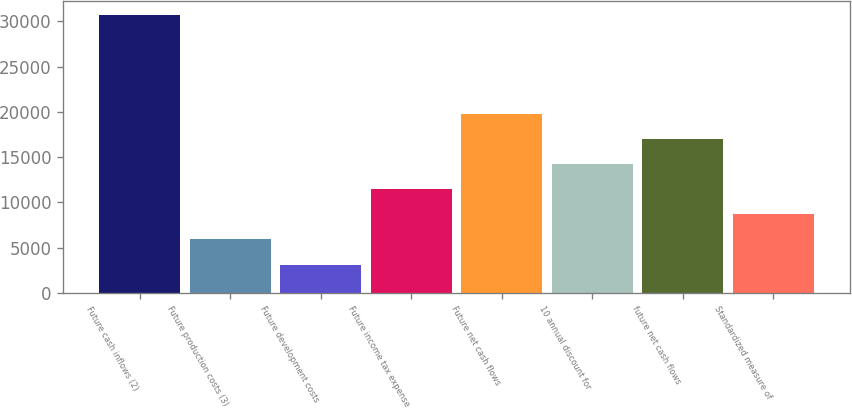Convert chart to OTSL. <chart><loc_0><loc_0><loc_500><loc_500><bar_chart><fcel>Future cash inflows (2)<fcel>Future production costs (3)<fcel>Future development costs<fcel>Future income tax expense<fcel>Future net cash flows<fcel>10 annual discount for<fcel>future net cash flows<fcel>Standardized measure of<nl><fcel>30733<fcel>5936<fcel>3136<fcel>11455.4<fcel>19734.5<fcel>14215.1<fcel>16974.8<fcel>8695.7<nl></chart> 